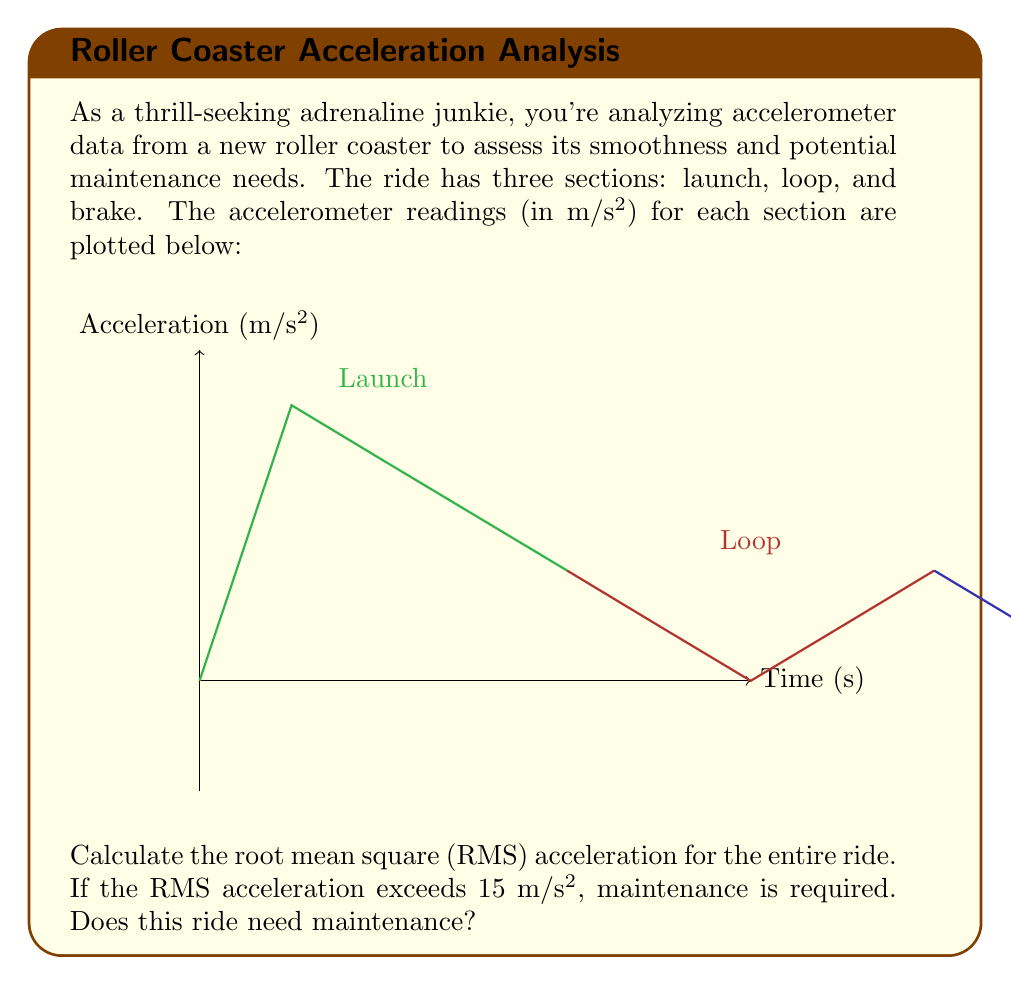What is the answer to this math problem? To solve this problem, we'll follow these steps:

1) First, we need to calculate the average acceleration for each section.

2) Then, we'll use these averages to calculate the RMS acceleration for the entire ride.

3) Finally, we'll compare the result to the 15 m/s² threshold.

Step 1: Calculate average acceleration for each section

Launch section: $(0 + 25 + 20 + 15 + 10) / 5 = 14$ m/s²
Loop section: $(10 + 5 + (-5) + 5 + 10) / 5 = 5$ m/s²
Brake section: $(10 + 5 + 0 + (-5) + 0) / 5 = 2$ m/s²

Step 2: Calculate RMS acceleration

The formula for RMS acceleration is:

$$ RMS = \sqrt{\frac{a_1^2 + a_2^2 + a_3^2}{3}} $$

Where $a_1$, $a_2$, and $a_3$ are the average accelerations for each section.

Substituting our values:

$$ RMS = \sqrt{\frac{14^2 + 5^2 + 2^2}{3}} $$

$$ RMS = \sqrt{\frac{196 + 25 + 4}{3}} = \sqrt{\frac{225}{3}} = \sqrt{75} = 8.66 $$ m/s²

Step 3: Compare to threshold

The calculated RMS acceleration (8.66 m/s²) is less than the 15 m/s² threshold.
Answer: 8.66 m/s²; No maintenance required 